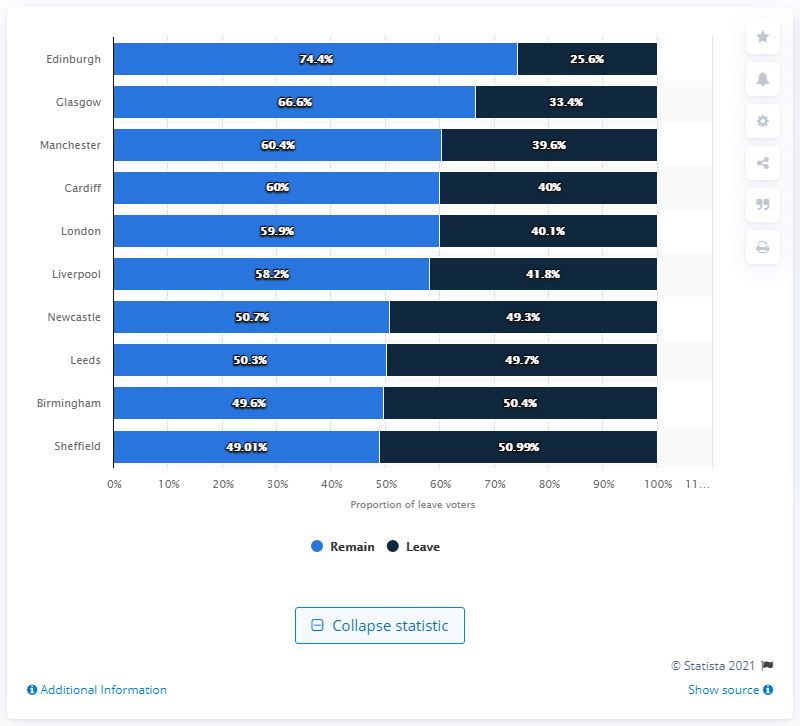Draw attention to some important aspects in this diagram. Birmingham is the second largest city in the United Kingdom. A recent study has revealed that the amount of leave taken by residents in Edinburgh is 25.6%. The total of remaining and leaving employees in Manchester is 100. 